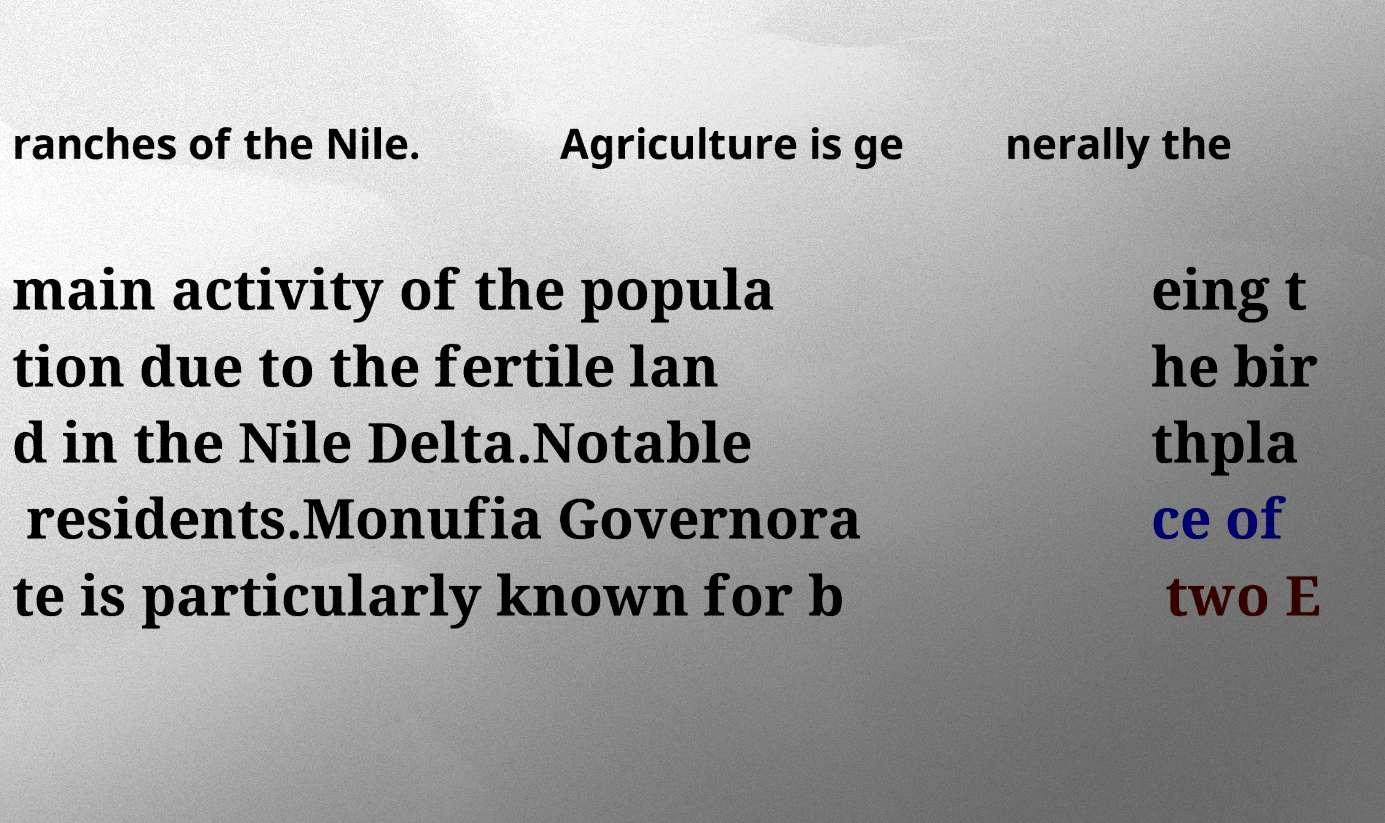Please identify and transcribe the text found in this image. ranches of the Nile. Agriculture is ge nerally the main activity of the popula tion due to the fertile lan d in the Nile Delta.Notable residents.Monufia Governora te is particularly known for b eing t he bir thpla ce of two E 